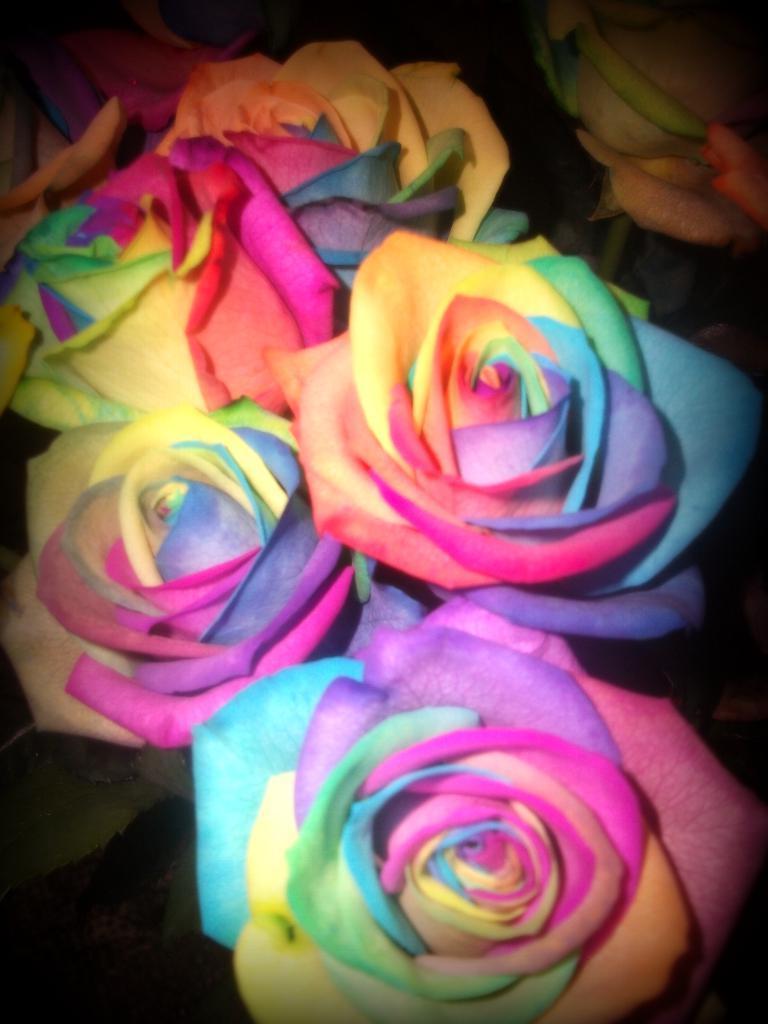In one or two sentences, can you explain what this image depicts? In this image I can see colorful roses. 